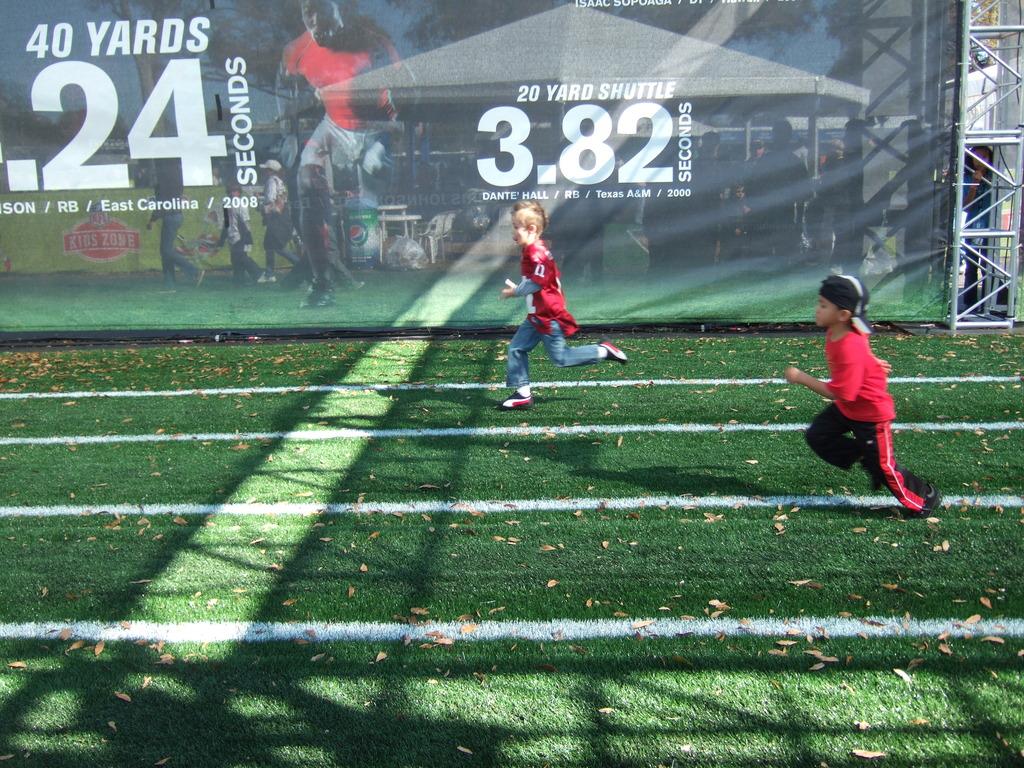Is this a race competition?
Keep it short and to the point. Yes. How many yards?
Make the answer very short. 20. 